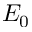<formula> <loc_0><loc_0><loc_500><loc_500>E _ { 0 }</formula> 